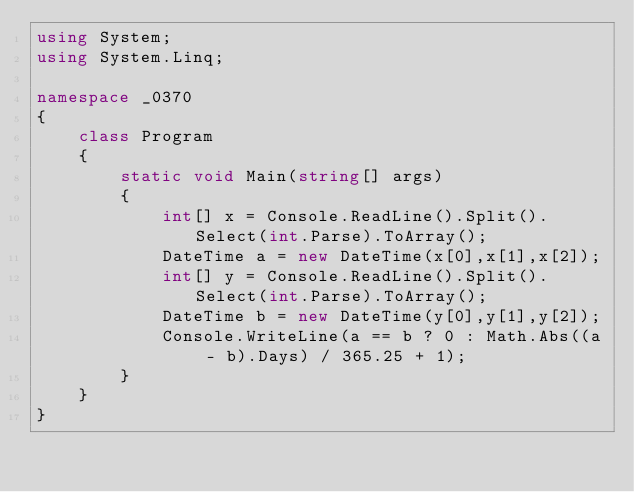Convert code to text. <code><loc_0><loc_0><loc_500><loc_500><_C#_>using System;
using System.Linq;

namespace _0370
{
    class Program
    {
        static void Main(string[] args)
        {
            int[] x = Console.ReadLine().Split().Select(int.Parse).ToArray();
            DateTime a = new DateTime(x[0],x[1],x[2]);
            int[] y = Console.ReadLine().Split().Select(int.Parse).ToArray();
            DateTime b = new DateTime(y[0],y[1],y[2]);
            Console.WriteLine(a == b ? 0 : Math.Abs((a - b).Days) / 365.25 + 1);
        }
    }
}
</code> 